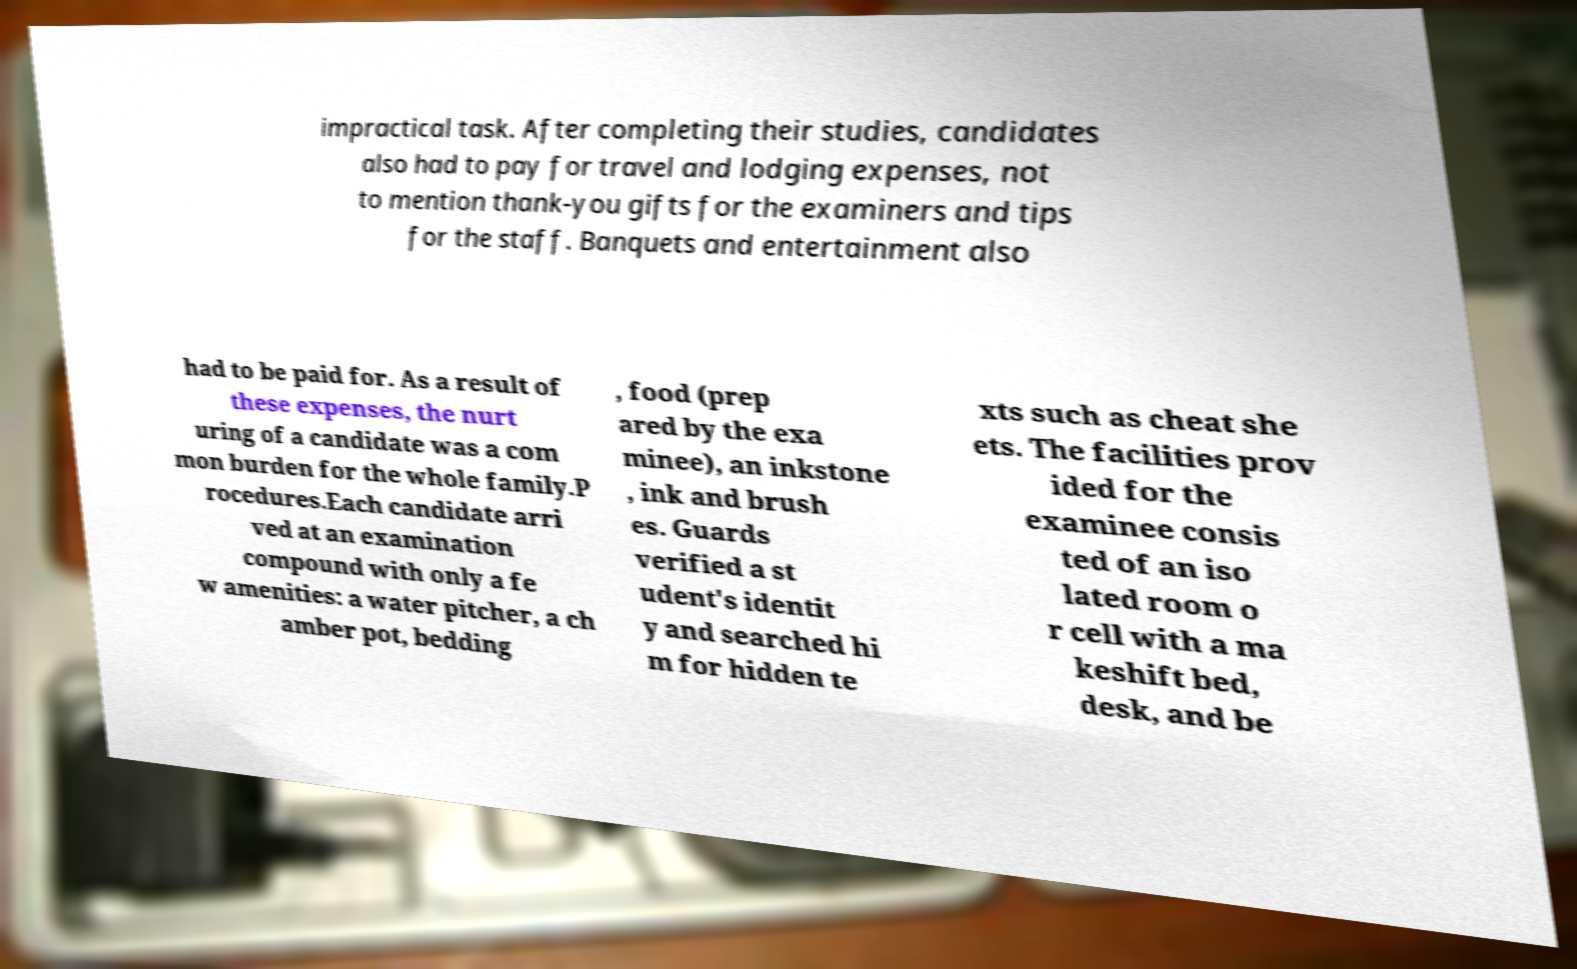Could you assist in decoding the text presented in this image and type it out clearly? impractical task. After completing their studies, candidates also had to pay for travel and lodging expenses, not to mention thank-you gifts for the examiners and tips for the staff. Banquets and entertainment also had to be paid for. As a result of these expenses, the nurt uring of a candidate was a com mon burden for the whole family.P rocedures.Each candidate arri ved at an examination compound with only a fe w amenities: a water pitcher, a ch amber pot, bedding , food (prep ared by the exa minee), an inkstone , ink and brush es. Guards verified a st udent's identit y and searched hi m for hidden te xts such as cheat she ets. The facilities prov ided for the examinee consis ted of an iso lated room o r cell with a ma keshift bed, desk, and be 